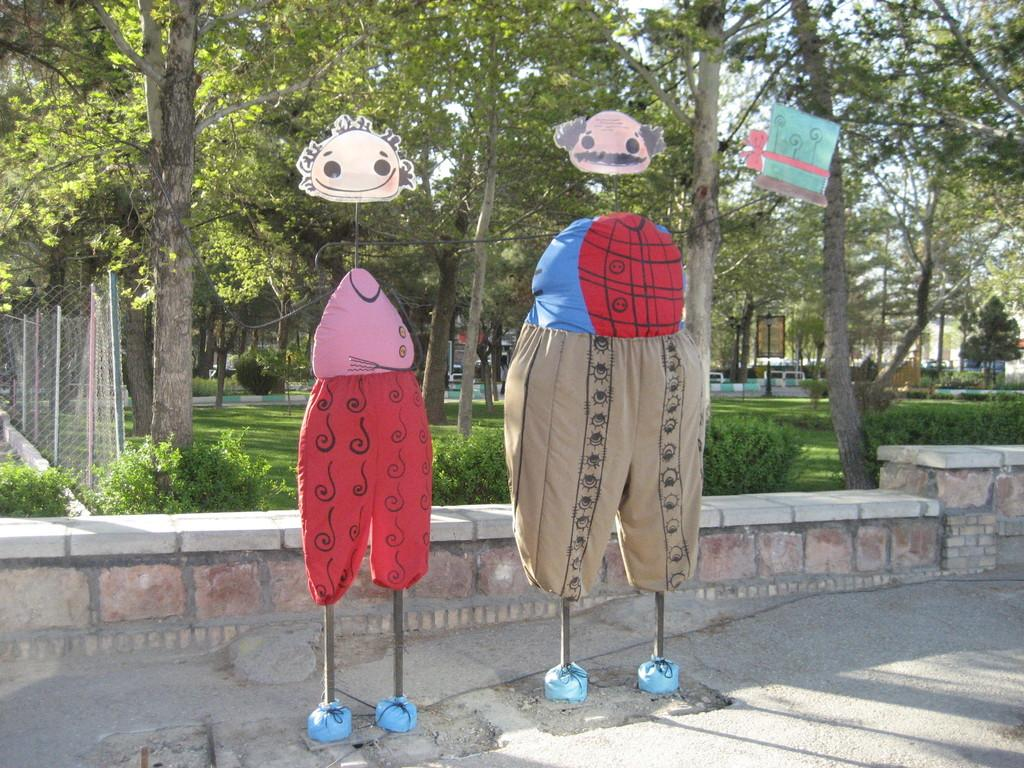What are the two main objects in the image? The two main objects in the image are in the shape of a man and a woman. Where are the man and woman-shaped objects located in the image? The man and woman-shaped objects are in the middle of the image. What type of nail is being used to lift the man-shaped object in the image? There is no nail or lifting action present in the image; the man and woman-shaped objects are stationary. How often do the man and woman-shaped objects wash their clothes in the image? There is no information about washing clothes in the image, as it only features the man and woman-shaped objects. 